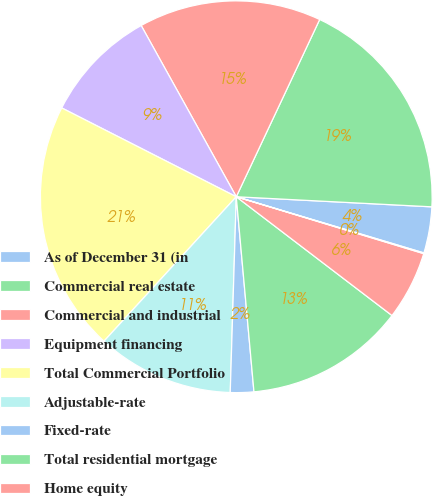Convert chart to OTSL. <chart><loc_0><loc_0><loc_500><loc_500><pie_chart><fcel>As of December 31 (in<fcel>Commercial real estate<fcel>Commercial and industrial<fcel>Equipment financing<fcel>Total Commercial Portfolio<fcel>Adjustable-rate<fcel>Fixed-rate<fcel>Total residential mortgage<fcel>Home equity<fcel>Other consumer<nl><fcel>3.81%<fcel>18.82%<fcel>15.07%<fcel>9.44%<fcel>20.69%<fcel>11.31%<fcel>1.93%<fcel>13.19%<fcel>5.68%<fcel>0.06%<nl></chart> 